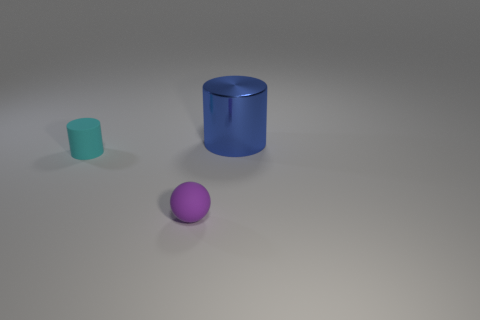Is there any other thing that has the same size as the blue thing?
Ensure brevity in your answer.  No. What is the color of the tiny object on the right side of the cylinder to the left of the large blue cylinder behind the matte sphere?
Provide a short and direct response. Purple. What color is the matte cylinder that is the same size as the purple sphere?
Your answer should be compact. Cyan. How many metallic things are either tiny cyan cylinders or big cyan cubes?
Keep it short and to the point. 0. The cylinder that is the same material as the small purple sphere is what color?
Your answer should be compact. Cyan. There is a cylinder on the right side of the cylinder that is left of the large shiny thing; what is its material?
Your answer should be compact. Metal. What number of objects are either objects that are on the left side of the blue metal cylinder or small things that are in front of the cyan cylinder?
Provide a succinct answer. 2. There is a matte object in front of the cylinder in front of the blue cylinder that is right of the small cyan cylinder; how big is it?
Ensure brevity in your answer.  Small. Are there the same number of small cylinders that are on the right side of the matte cylinder and metal cylinders?
Your answer should be compact. No. Is there any other thing that is the same shape as the purple thing?
Provide a short and direct response. No. 